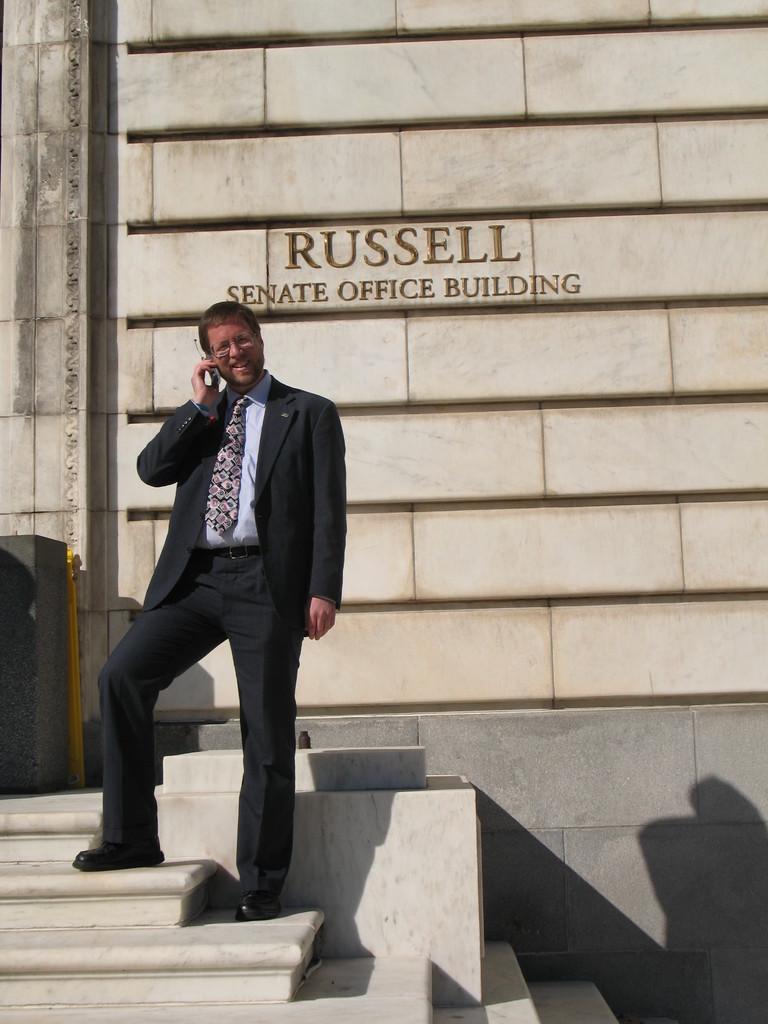Please provide a concise description of this image. In this picture we can see a man and in the background we can see a wall with a name on it. 